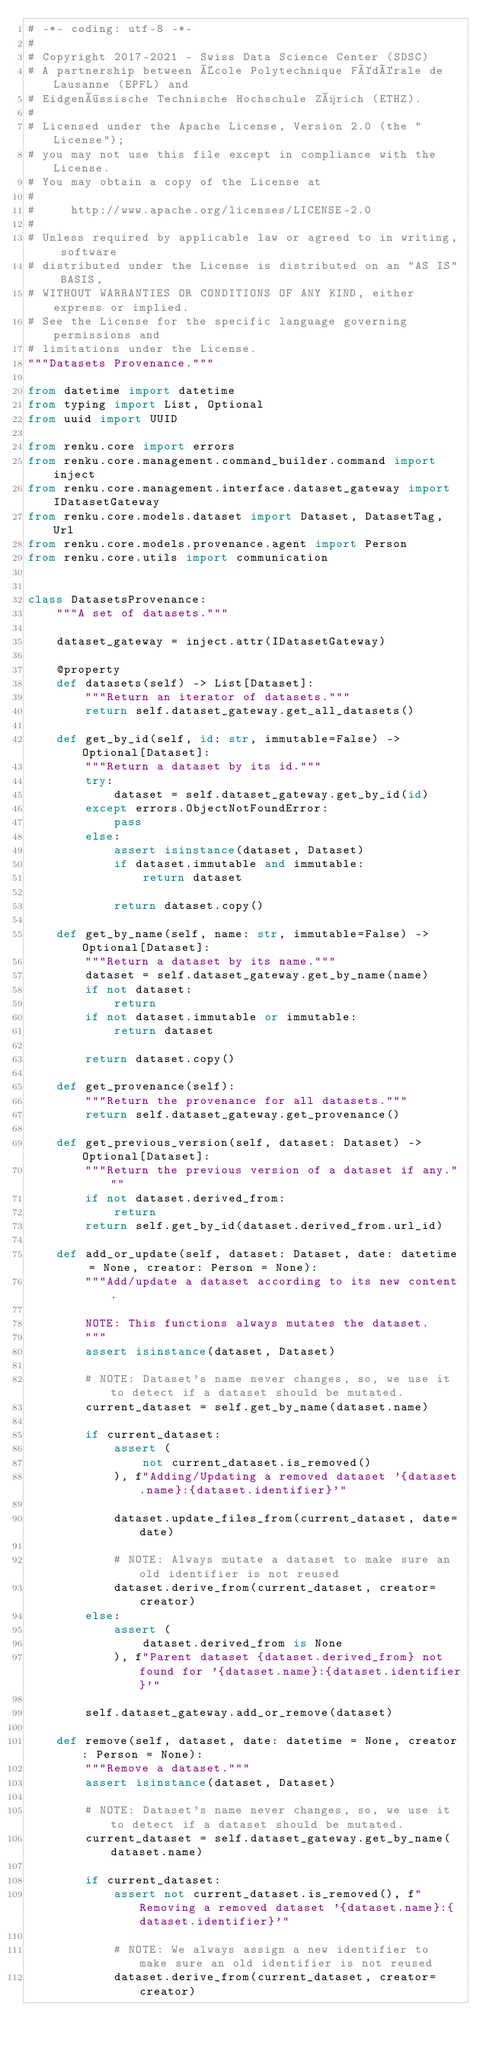<code> <loc_0><loc_0><loc_500><loc_500><_Python_># -*- coding: utf-8 -*-
#
# Copyright 2017-2021 - Swiss Data Science Center (SDSC)
# A partnership between École Polytechnique Fédérale de Lausanne (EPFL) and
# Eidgenössische Technische Hochschule Zürich (ETHZ).
#
# Licensed under the Apache License, Version 2.0 (the "License");
# you may not use this file except in compliance with the License.
# You may obtain a copy of the License at
#
#     http://www.apache.org/licenses/LICENSE-2.0
#
# Unless required by applicable law or agreed to in writing, software
# distributed under the License is distributed on an "AS IS" BASIS,
# WITHOUT WARRANTIES OR CONDITIONS OF ANY KIND, either express or implied.
# See the License for the specific language governing permissions and
# limitations under the License.
"""Datasets Provenance."""

from datetime import datetime
from typing import List, Optional
from uuid import UUID

from renku.core import errors
from renku.core.management.command_builder.command import inject
from renku.core.management.interface.dataset_gateway import IDatasetGateway
from renku.core.models.dataset import Dataset, DatasetTag, Url
from renku.core.models.provenance.agent import Person
from renku.core.utils import communication


class DatasetsProvenance:
    """A set of datasets."""

    dataset_gateway = inject.attr(IDatasetGateway)

    @property
    def datasets(self) -> List[Dataset]:
        """Return an iterator of datasets."""
        return self.dataset_gateway.get_all_datasets()

    def get_by_id(self, id: str, immutable=False) -> Optional[Dataset]:
        """Return a dataset by its id."""
        try:
            dataset = self.dataset_gateway.get_by_id(id)
        except errors.ObjectNotFoundError:
            pass
        else:
            assert isinstance(dataset, Dataset)
            if dataset.immutable and immutable:
                return dataset

            return dataset.copy()

    def get_by_name(self, name: str, immutable=False) -> Optional[Dataset]:
        """Return a dataset by its name."""
        dataset = self.dataset_gateway.get_by_name(name)
        if not dataset:
            return
        if not dataset.immutable or immutable:
            return dataset

        return dataset.copy()

    def get_provenance(self):
        """Return the provenance for all datasets."""
        return self.dataset_gateway.get_provenance()

    def get_previous_version(self, dataset: Dataset) -> Optional[Dataset]:
        """Return the previous version of a dataset if any."""
        if not dataset.derived_from:
            return
        return self.get_by_id(dataset.derived_from.url_id)

    def add_or_update(self, dataset: Dataset, date: datetime = None, creator: Person = None):
        """Add/update a dataset according to its new content.

        NOTE: This functions always mutates the dataset.
        """
        assert isinstance(dataset, Dataset)

        # NOTE: Dataset's name never changes, so, we use it to detect if a dataset should be mutated.
        current_dataset = self.get_by_name(dataset.name)

        if current_dataset:
            assert (
                not current_dataset.is_removed()
            ), f"Adding/Updating a removed dataset '{dataset.name}:{dataset.identifier}'"

            dataset.update_files_from(current_dataset, date=date)

            # NOTE: Always mutate a dataset to make sure an old identifier is not reused
            dataset.derive_from(current_dataset, creator=creator)
        else:
            assert (
                dataset.derived_from is None
            ), f"Parent dataset {dataset.derived_from} not found for '{dataset.name}:{dataset.identifier}'"

        self.dataset_gateway.add_or_remove(dataset)

    def remove(self, dataset, date: datetime = None, creator: Person = None):
        """Remove a dataset."""
        assert isinstance(dataset, Dataset)

        # NOTE: Dataset's name never changes, so, we use it to detect if a dataset should be mutated.
        current_dataset = self.dataset_gateway.get_by_name(dataset.name)

        if current_dataset:
            assert not current_dataset.is_removed(), f"Removing a removed dataset '{dataset.name}:{dataset.identifier}'"

            # NOTE: We always assign a new identifier to make sure an old identifier is not reused
            dataset.derive_from(current_dataset, creator=creator)</code> 